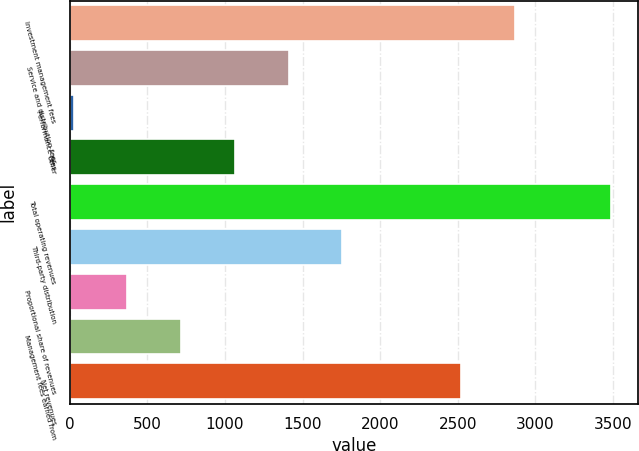Convert chart to OTSL. <chart><loc_0><loc_0><loc_500><loc_500><bar_chart><fcel>Investment management fees<fcel>Service and distribution fees<fcel>Performance fees<fcel>Other<fcel>Total operating revenues<fcel>Third-party distribution<fcel>Proportional share of revenues<fcel>Management fees earned from<fcel>Net revenues<nl><fcel>2867.26<fcel>1410.74<fcel>26.1<fcel>1064.58<fcel>3487.7<fcel>1756.9<fcel>372.26<fcel>718.42<fcel>2521.1<nl></chart> 